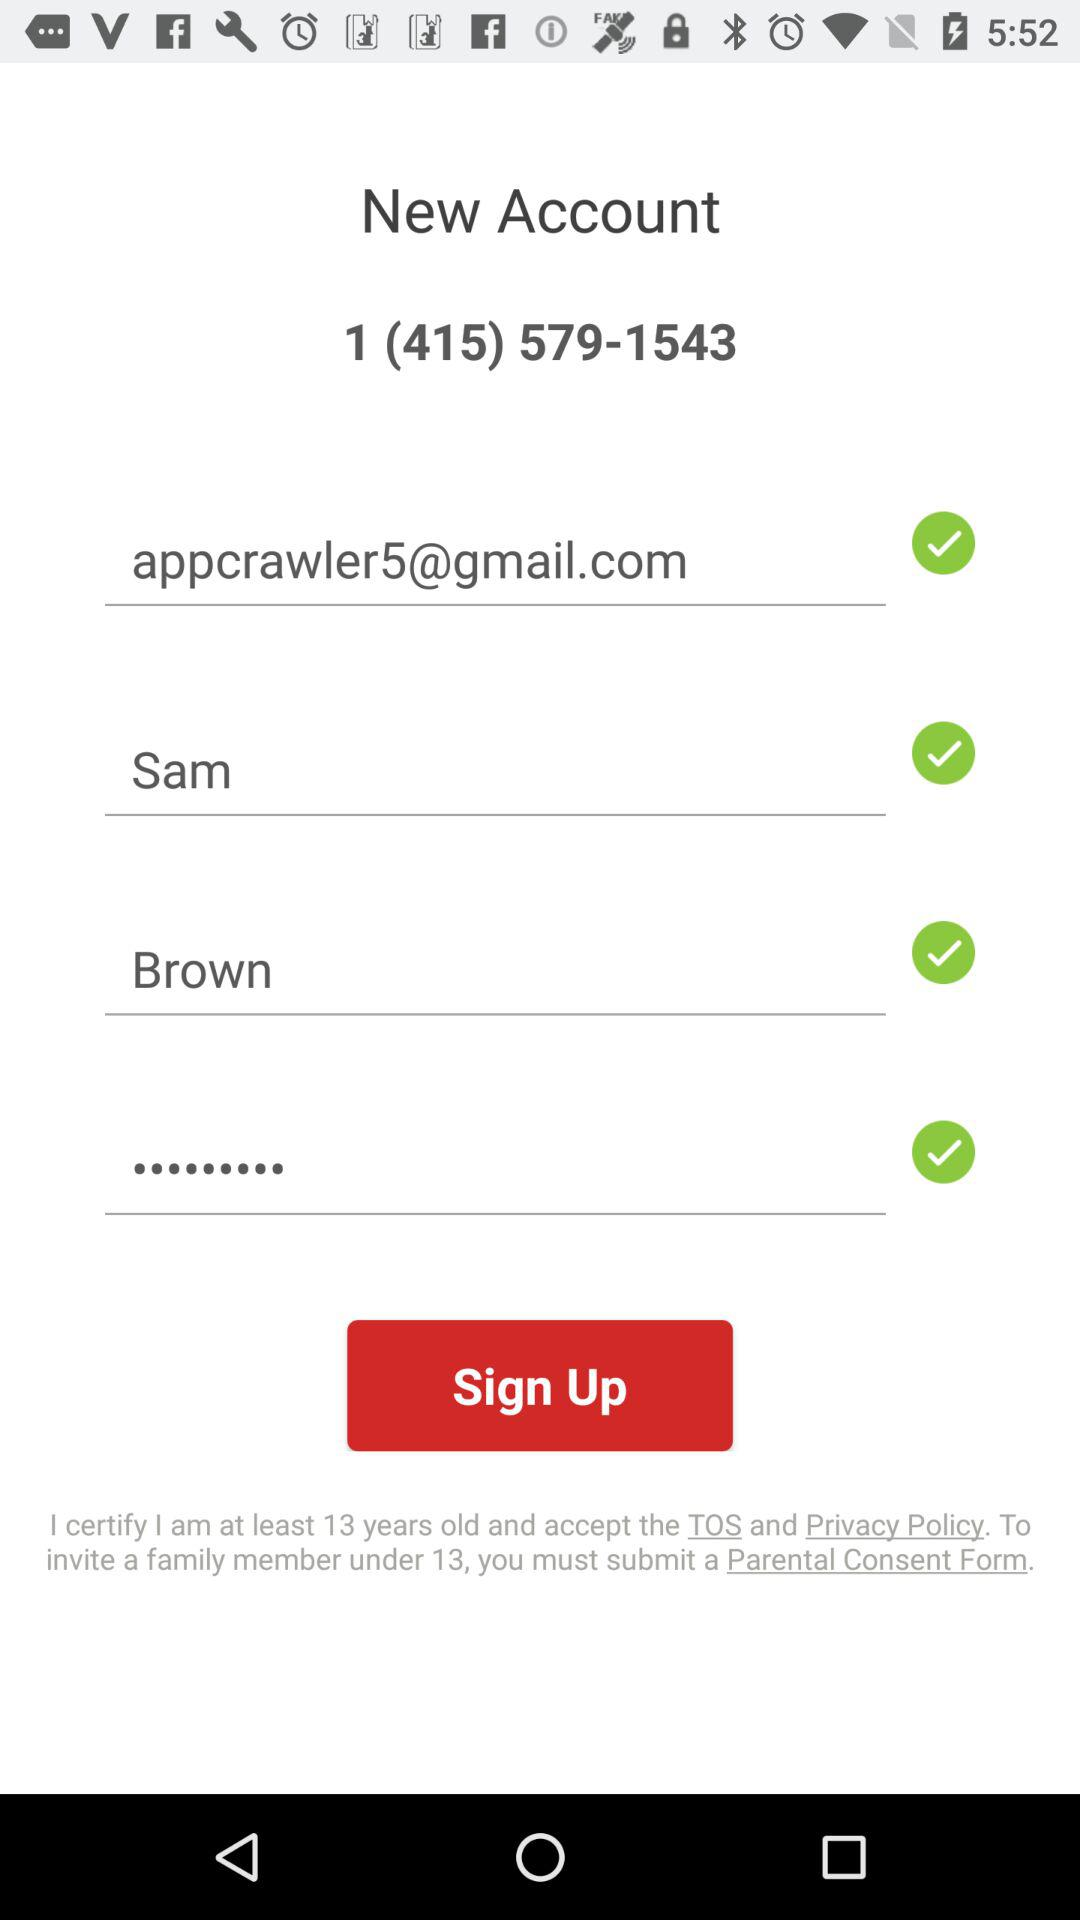What is the contact number? The contact number is 1 (415) 579-1543. 